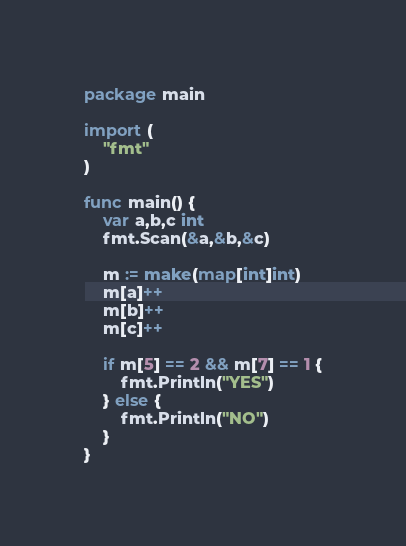Convert code to text. <code><loc_0><loc_0><loc_500><loc_500><_Go_>package main

import (
	"fmt"
)

func main() {
	var a,b,c int
	fmt.Scan(&a,&b,&c)

	m := make(map[int]int)
	m[a]++
	m[b]++
	m[c]++

	if m[5] == 2 && m[7] == 1 {
		fmt.Println("YES")
	} else {
		fmt.Println("NO")
	}
}
</code> 